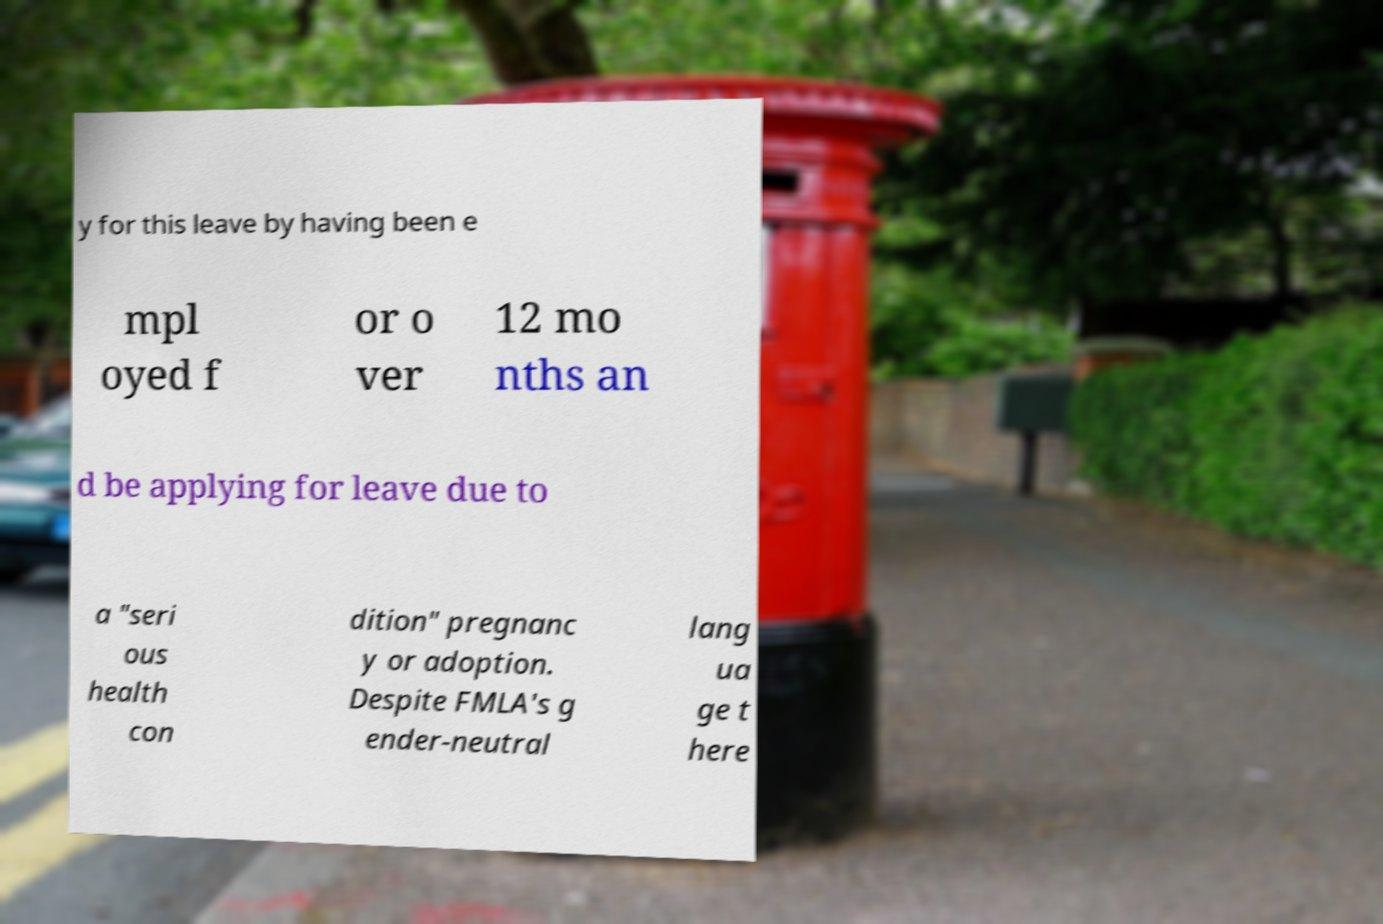Can you read and provide the text displayed in the image?This photo seems to have some interesting text. Can you extract and type it out for me? y for this leave by having been e mpl oyed f or o ver 12 mo nths an d be applying for leave due to a "seri ous health con dition" pregnanc y or adoption. Despite FMLA's g ender-neutral lang ua ge t here 